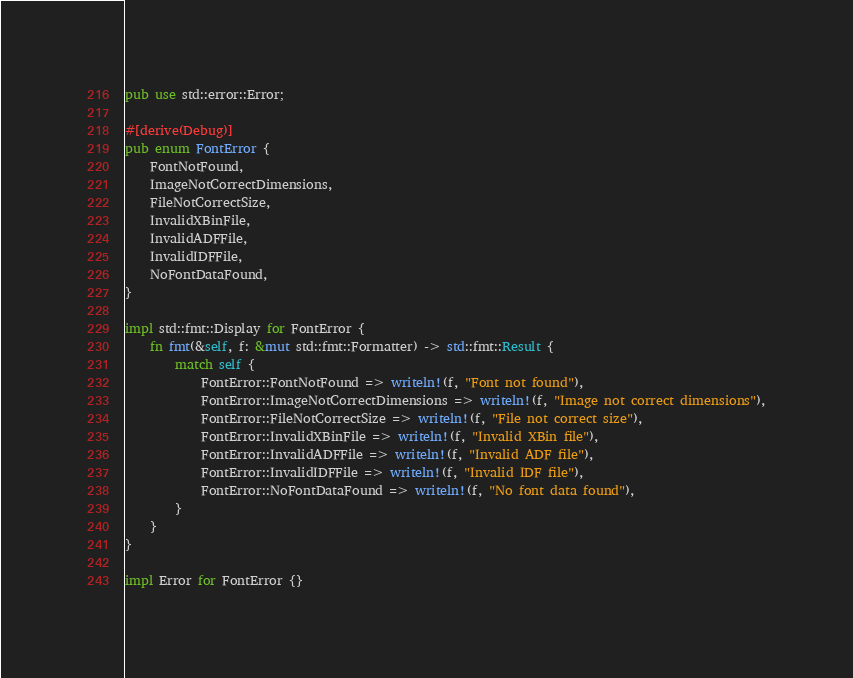<code> <loc_0><loc_0><loc_500><loc_500><_Rust_>pub use std::error::Error;

#[derive(Debug)]
pub enum FontError {
    FontNotFound,
    ImageNotCorrectDimensions,
    FileNotCorrectSize,
    InvalidXBinFile,
    InvalidADFFile,
    InvalidIDFFile,
    NoFontDataFound,
}

impl std::fmt::Display for FontError {
    fn fmt(&self, f: &mut std::fmt::Formatter) -> std::fmt::Result {
        match self {
            FontError::FontNotFound => writeln!(f, "Font not found"),
            FontError::ImageNotCorrectDimensions => writeln!(f, "Image not correct dimensions"),
            FontError::FileNotCorrectSize => writeln!(f, "File not correct size"),
            FontError::InvalidXBinFile => writeln!(f, "Invalid XBin file"),
            FontError::InvalidADFFile => writeln!(f, "Invalid ADF file"),
            FontError::InvalidIDFFile => writeln!(f, "Invalid IDF file"),
            FontError::NoFontDataFound => writeln!(f, "No font data found"),
        }
    }
}

impl Error for FontError {}
</code> 